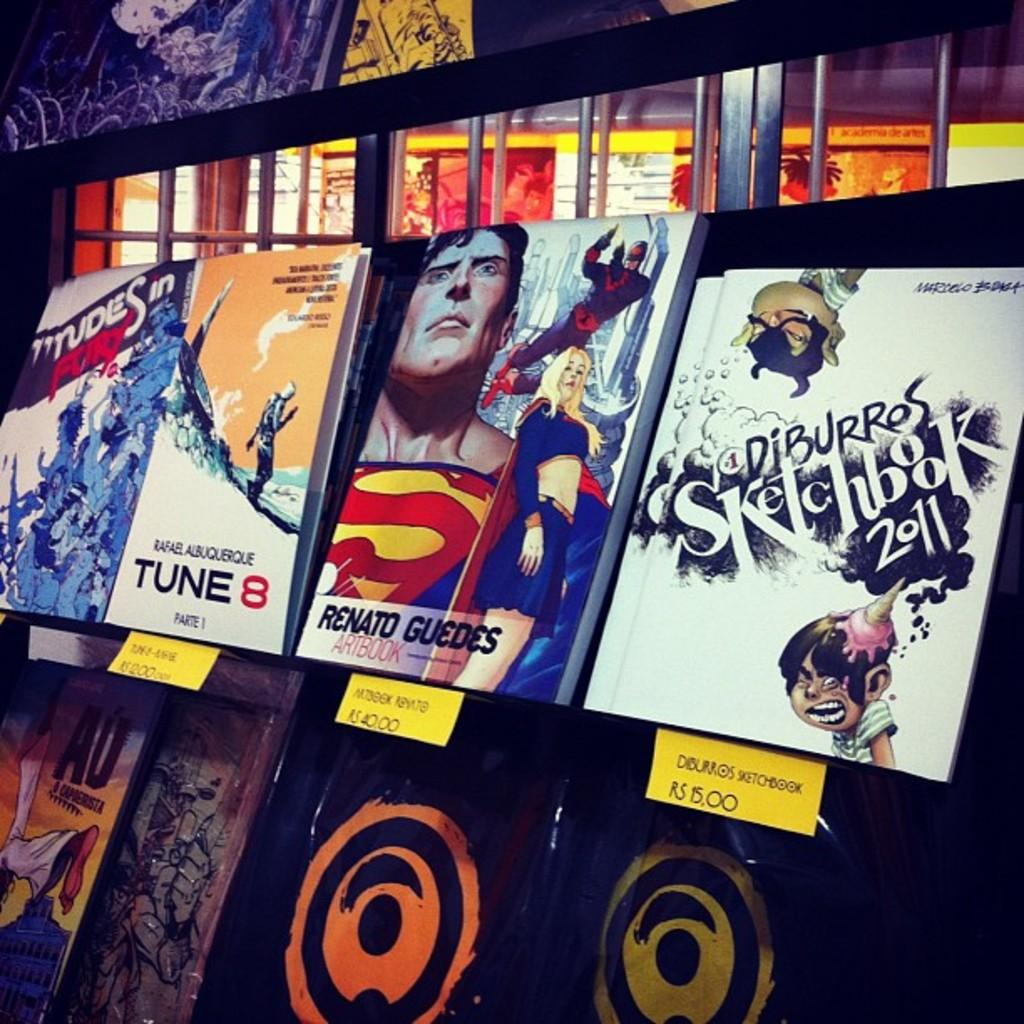<image>
Present a compact description of the photo's key features. A Diburros Sketchbook 2011 comic book is displayed on a rack with other comic books. 